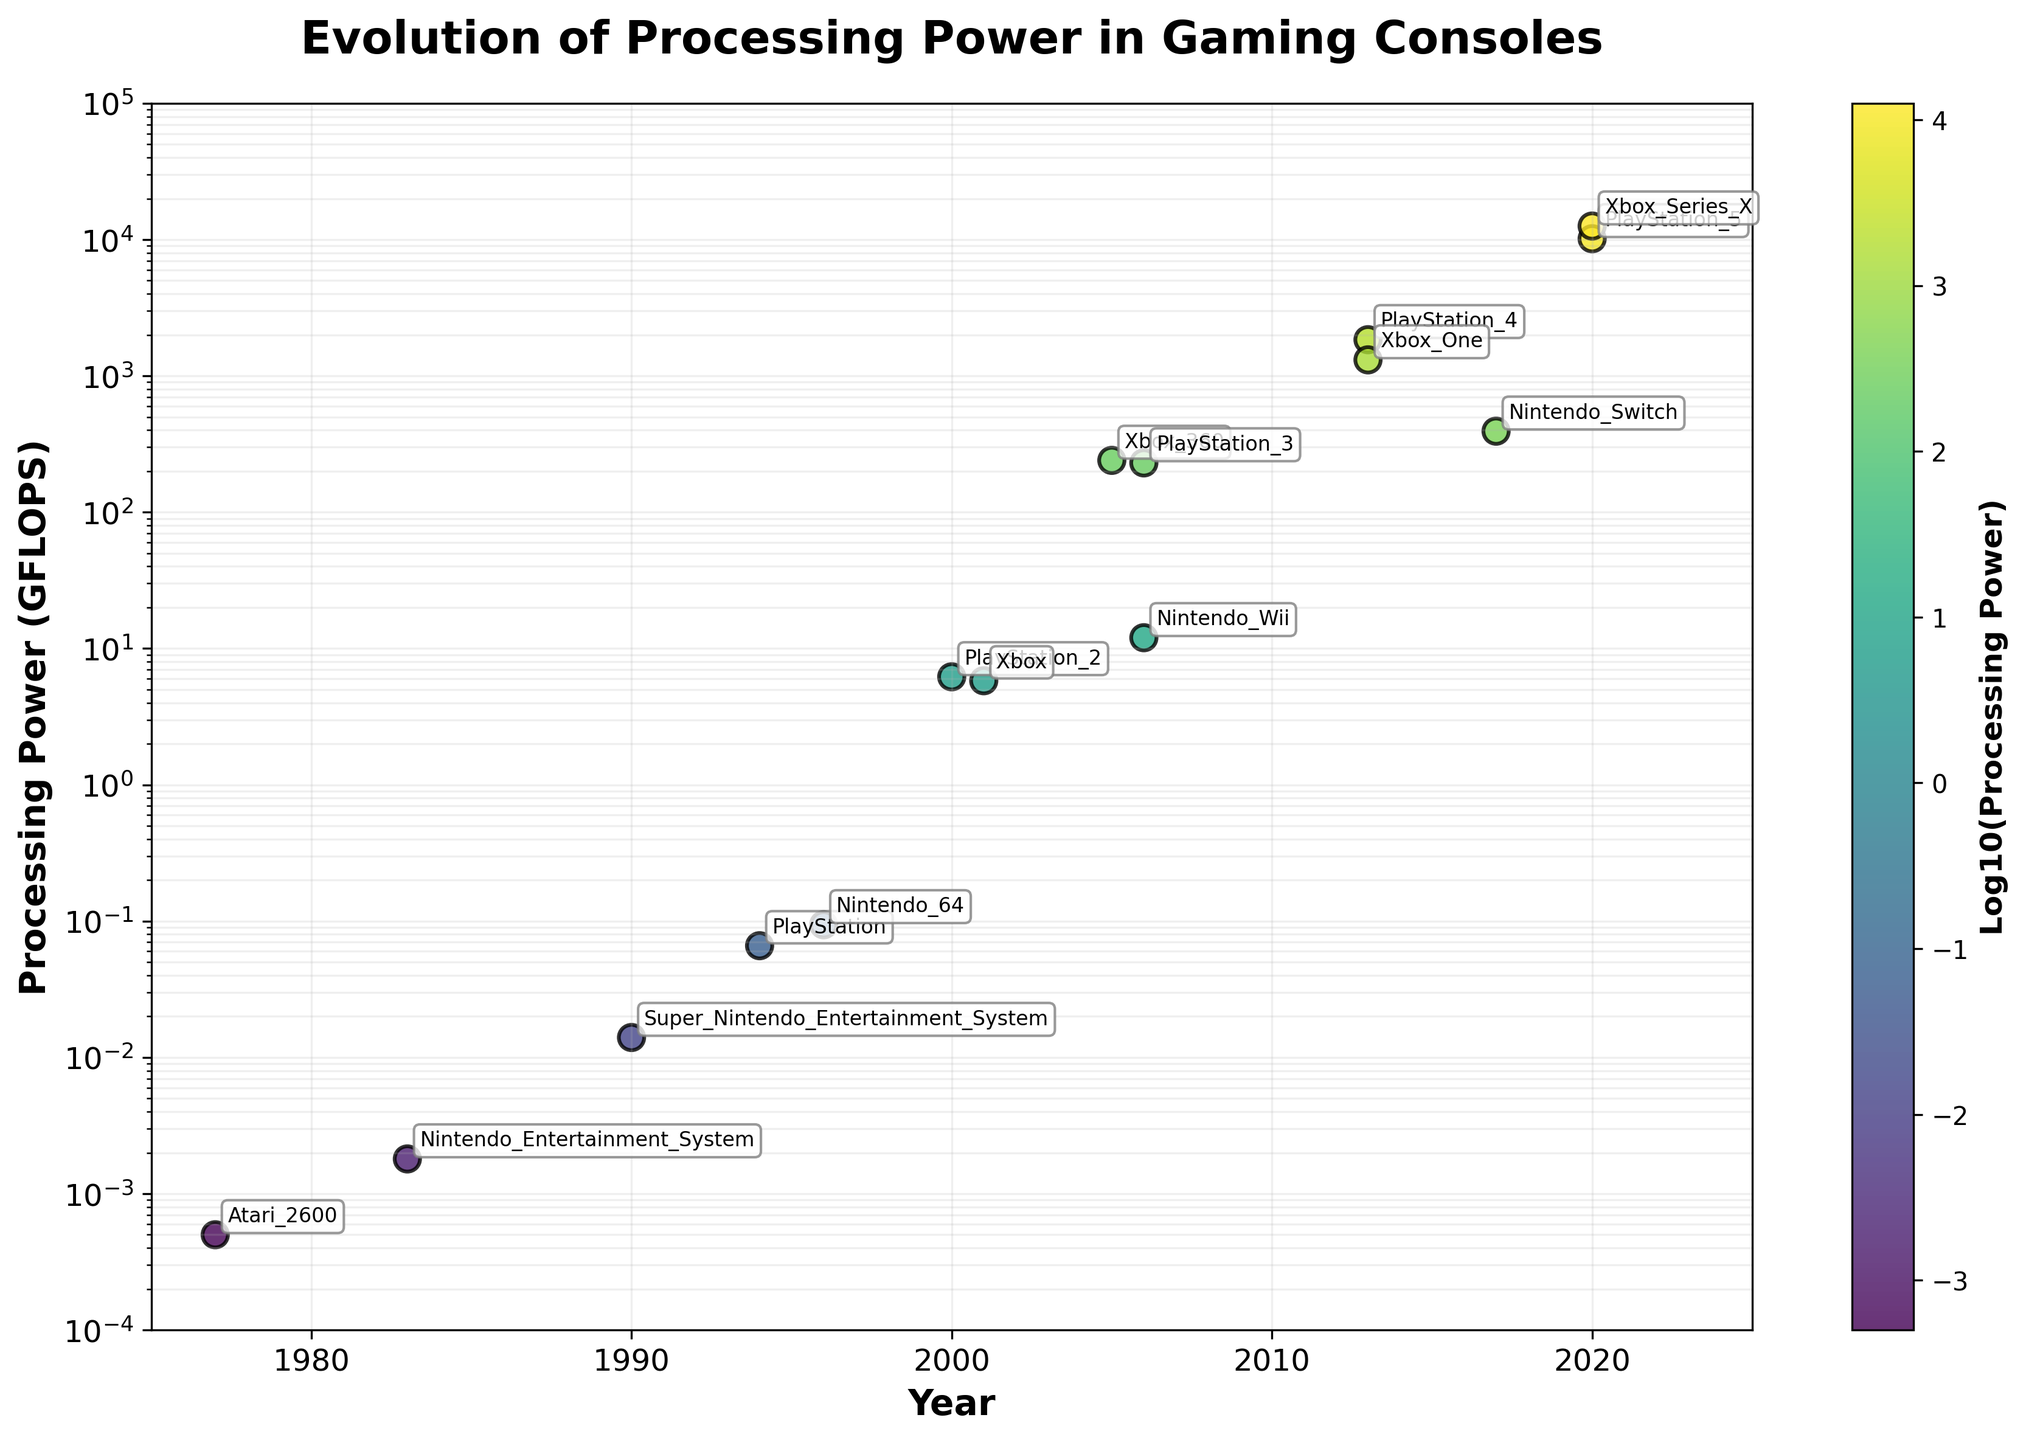What is the title of the plot? The title of the plot is clearly written at the top in large, bold font.
Answer: Evolution of Processing Power in Gaming Consoles What is the processing power of the PlayStation 4 in GFLOPS? To find this, we locate the PlayStation 4 label on the plot and see the corresponding y-axis value.
Answer: 1843 GFLOPS How many consoles are represented in the plot? Count the number of unique console labels annotated on the plot.
Answer: 15 consoles Which console had the highest processing power in 2020? Compare the processing power values of the consoles labeled with 2020 on the x-axis.
Answer: Xbox Series X What is the range of the y-axis? The y-axis is scaled logarithmically and ranges from the smallest to the largest value visible in the plot.
Answer: 1e-4 to 1e5 How does processing power change from PlayStation to PlayStation 2? Compare the processing power values for PlayStation (1994) and PlayStation 2 (2000) on the y-axis.
Answer: Increased from 0.066 GFLOPS to 6.2 GFLOPS What trend do you observe in the processing power of gaming consoles over time? The y-axis has a logarithmic scale, which indicates the processing power increases exponentially over the years.
Answer: Exponential increase Which console had higher processing power: Xbox 360 or PlayStation 3? Locate Xbox 360 and PlayStation 3 on the plot and compare their y-axis values.
Answer: Xbox 360 (240 GFLOPS) What's the approximate processing power of gaming consoles released in 2006? Identify the consoles released in 2006 and note their y-axis values.
Answer: 230 GFLOPS (PlayStation 3) and 12 GFLOPS (Nintendo Wii) What is the most recent console on the plot and its processing power? Find the console labeled with the most recent year and note its corresponding y-axis value.
Answer: Xbox Series X, 12570 GFLOPS 